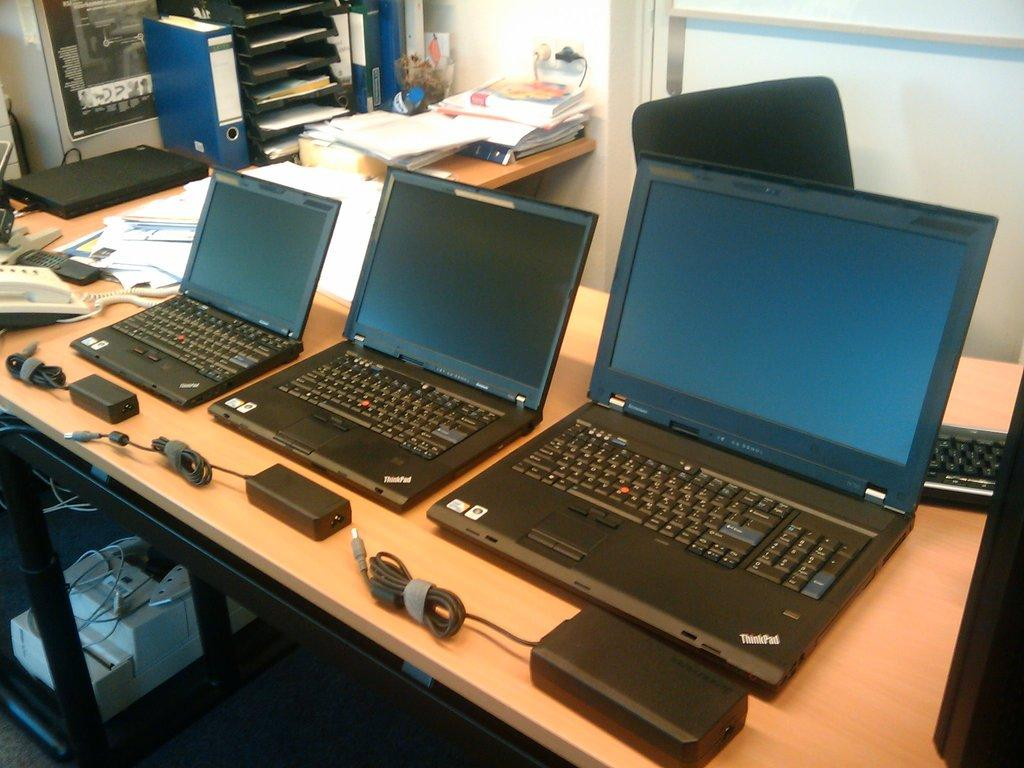Provide a one-sentence caption for the provided image. Three laptops of differing sizes all have ThinkPad displayed in the corner. 